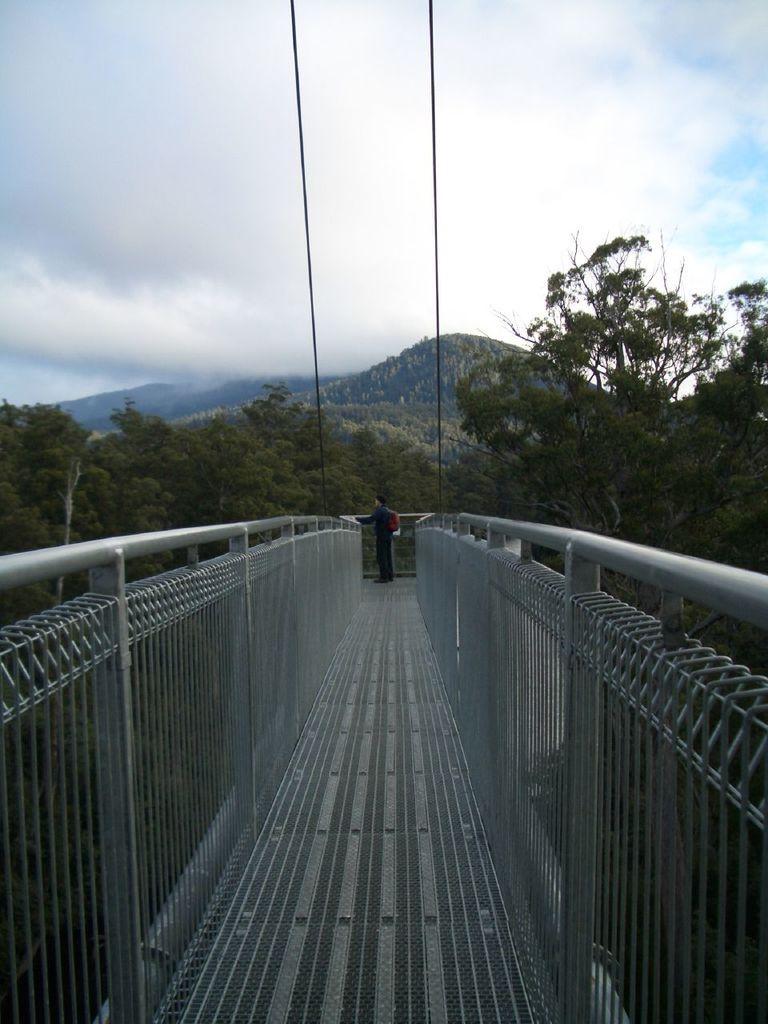Please provide a concise description of this image. Here we can see a bridge. In the background there is a person standing and we can see ropes,trees,mountains and clouds in the sky. 